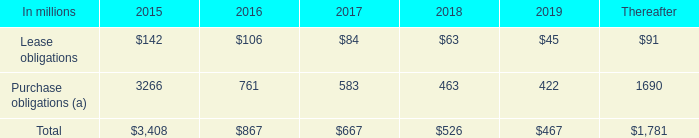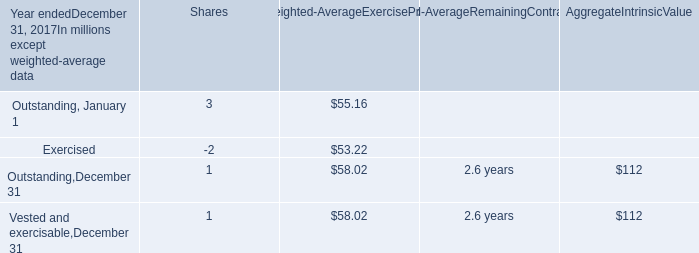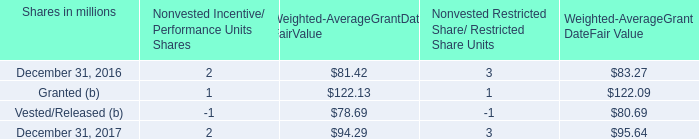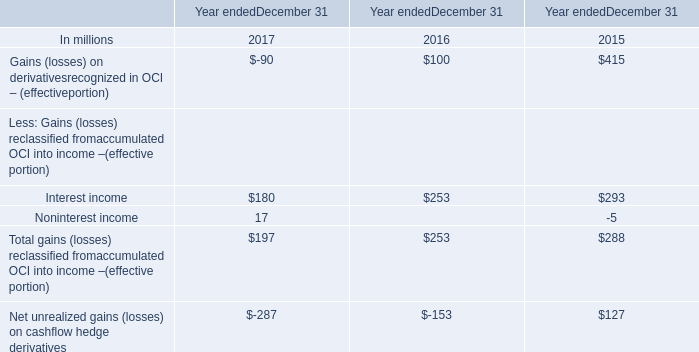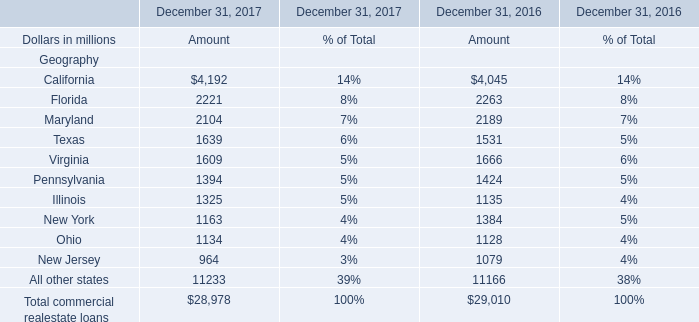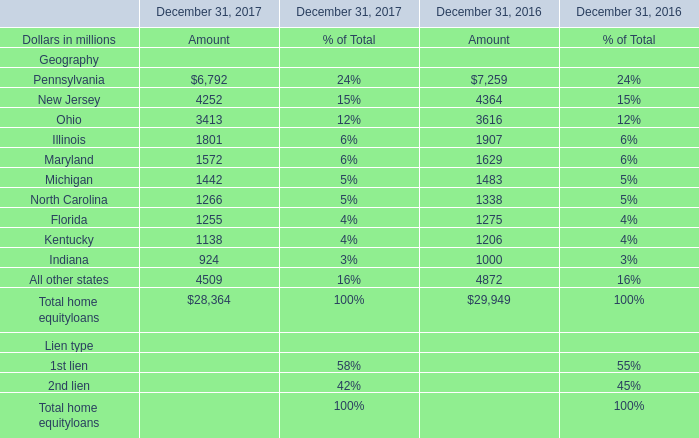What is the sum of home equity loans in 2017? (in million) 
Computations: ((((((((((6792 + 4252) + 3413) + 1801) + 1572) + 1442) + 1266) + 1255) + 1138) + 924) + 4509)
Answer: 28364.0. 